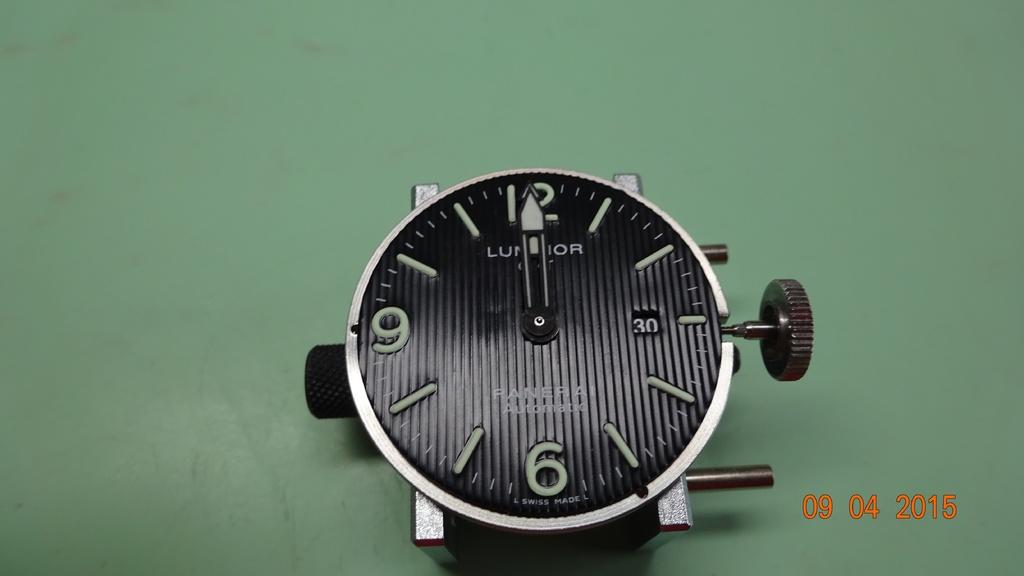What time does the clock say?
Offer a very short reply. 12:00. 